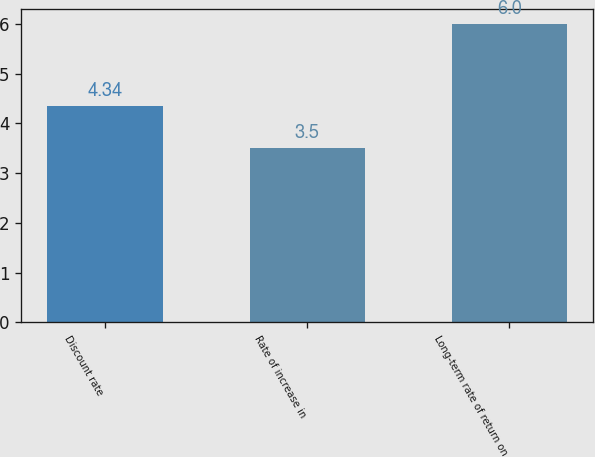Convert chart. <chart><loc_0><loc_0><loc_500><loc_500><bar_chart><fcel>Discount rate<fcel>Rate of increase in<fcel>Long-term rate of return on<nl><fcel>4.34<fcel>3.5<fcel>6<nl></chart> 